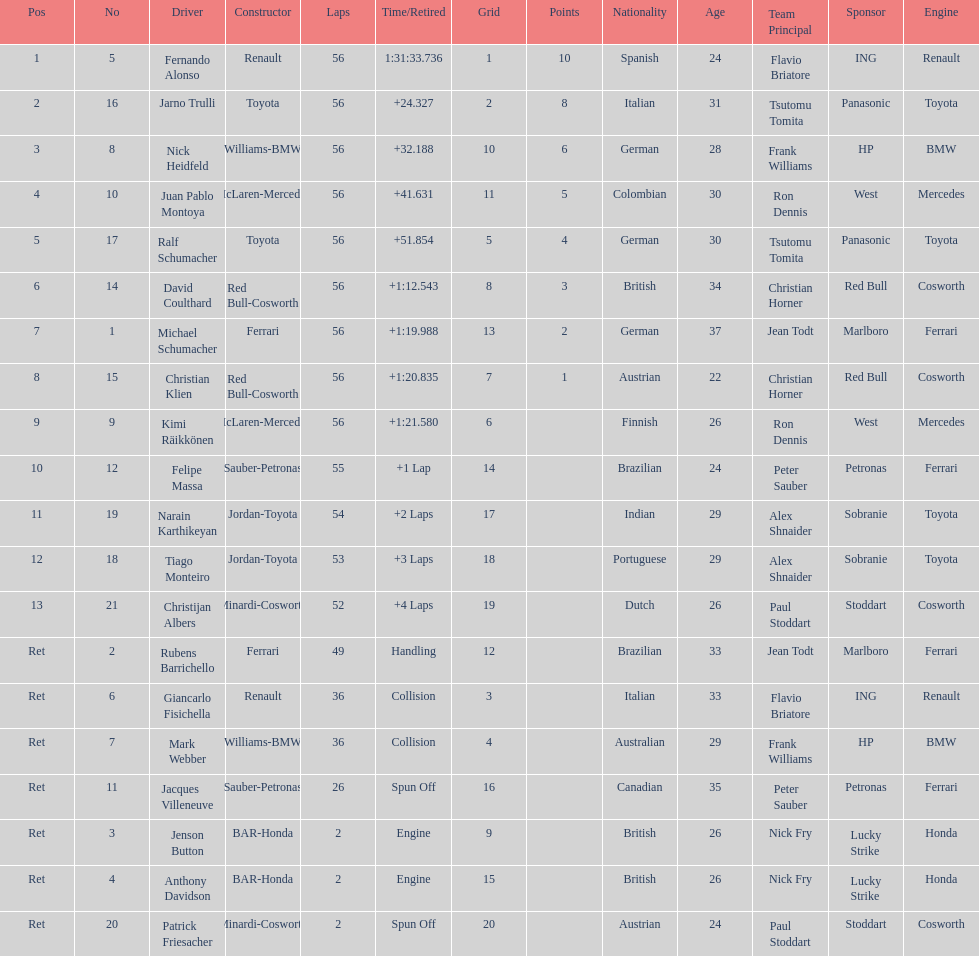Jarno trulli was not french but what nationality? Italian. 